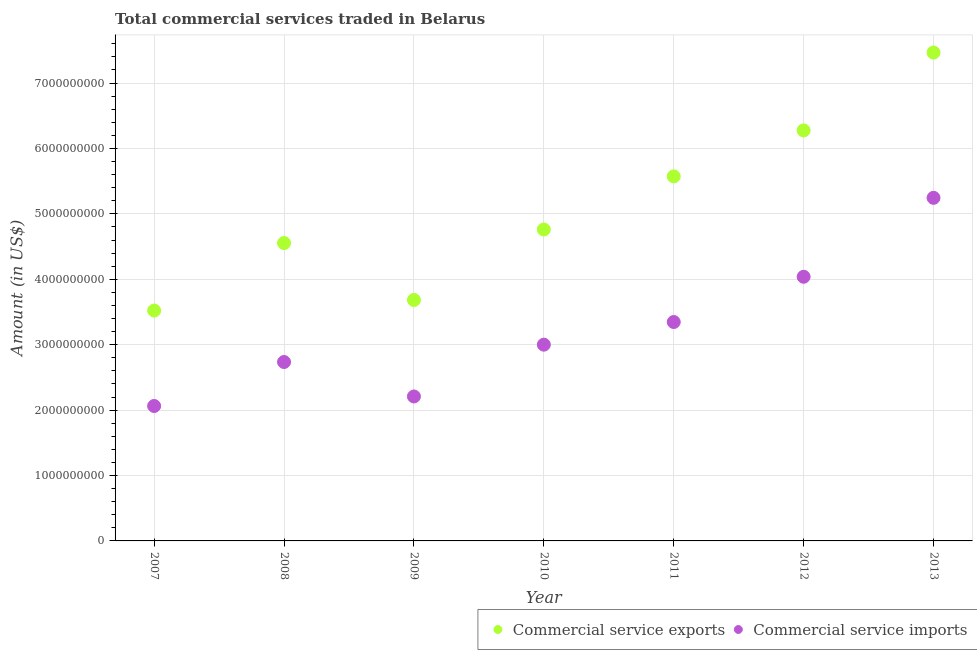Is the number of dotlines equal to the number of legend labels?
Provide a short and direct response. Yes. What is the amount of commercial service imports in 2011?
Keep it short and to the point. 3.35e+09. Across all years, what is the maximum amount of commercial service imports?
Provide a succinct answer. 5.24e+09. Across all years, what is the minimum amount of commercial service exports?
Offer a terse response. 3.52e+09. In which year was the amount of commercial service exports maximum?
Offer a terse response. 2013. What is the total amount of commercial service imports in the graph?
Ensure brevity in your answer.  2.26e+1. What is the difference between the amount of commercial service exports in 2007 and that in 2010?
Your response must be concise. -1.24e+09. What is the difference between the amount of commercial service imports in 2013 and the amount of commercial service exports in 2008?
Your answer should be very brief. 6.92e+08. What is the average amount of commercial service imports per year?
Give a very brief answer. 3.23e+09. In the year 2008, what is the difference between the amount of commercial service exports and amount of commercial service imports?
Give a very brief answer. 1.82e+09. What is the ratio of the amount of commercial service imports in 2010 to that in 2011?
Offer a very short reply. 0.9. Is the amount of commercial service imports in 2007 less than that in 2008?
Offer a terse response. Yes. What is the difference between the highest and the second highest amount of commercial service exports?
Offer a terse response. 1.19e+09. What is the difference between the highest and the lowest amount of commercial service imports?
Offer a very short reply. 3.18e+09. In how many years, is the amount of commercial service imports greater than the average amount of commercial service imports taken over all years?
Give a very brief answer. 3. Is the sum of the amount of commercial service imports in 2007 and 2011 greater than the maximum amount of commercial service exports across all years?
Make the answer very short. No. Is the amount of commercial service imports strictly greater than the amount of commercial service exports over the years?
Your response must be concise. No. How many years are there in the graph?
Ensure brevity in your answer.  7. Are the values on the major ticks of Y-axis written in scientific E-notation?
Your answer should be very brief. No. Does the graph contain any zero values?
Give a very brief answer. No. Where does the legend appear in the graph?
Provide a short and direct response. Bottom right. How many legend labels are there?
Your answer should be compact. 2. How are the legend labels stacked?
Provide a succinct answer. Horizontal. What is the title of the graph?
Keep it short and to the point. Total commercial services traded in Belarus. What is the label or title of the X-axis?
Offer a terse response. Year. What is the label or title of the Y-axis?
Offer a very short reply. Amount (in US$). What is the Amount (in US$) in Commercial service exports in 2007?
Offer a terse response. 3.52e+09. What is the Amount (in US$) in Commercial service imports in 2007?
Give a very brief answer. 2.06e+09. What is the Amount (in US$) in Commercial service exports in 2008?
Offer a very short reply. 4.55e+09. What is the Amount (in US$) in Commercial service imports in 2008?
Your answer should be very brief. 2.74e+09. What is the Amount (in US$) of Commercial service exports in 2009?
Ensure brevity in your answer.  3.68e+09. What is the Amount (in US$) of Commercial service imports in 2009?
Give a very brief answer. 2.21e+09. What is the Amount (in US$) of Commercial service exports in 2010?
Provide a short and direct response. 4.76e+09. What is the Amount (in US$) in Commercial service imports in 2010?
Keep it short and to the point. 3.00e+09. What is the Amount (in US$) in Commercial service exports in 2011?
Give a very brief answer. 5.57e+09. What is the Amount (in US$) of Commercial service imports in 2011?
Keep it short and to the point. 3.35e+09. What is the Amount (in US$) in Commercial service exports in 2012?
Your answer should be very brief. 6.28e+09. What is the Amount (in US$) in Commercial service imports in 2012?
Your answer should be compact. 4.04e+09. What is the Amount (in US$) in Commercial service exports in 2013?
Offer a terse response. 7.47e+09. What is the Amount (in US$) in Commercial service imports in 2013?
Your answer should be compact. 5.24e+09. Across all years, what is the maximum Amount (in US$) of Commercial service exports?
Make the answer very short. 7.47e+09. Across all years, what is the maximum Amount (in US$) in Commercial service imports?
Provide a succinct answer. 5.24e+09. Across all years, what is the minimum Amount (in US$) of Commercial service exports?
Ensure brevity in your answer.  3.52e+09. Across all years, what is the minimum Amount (in US$) in Commercial service imports?
Provide a short and direct response. 2.06e+09. What is the total Amount (in US$) of Commercial service exports in the graph?
Keep it short and to the point. 3.58e+1. What is the total Amount (in US$) of Commercial service imports in the graph?
Your response must be concise. 2.26e+1. What is the difference between the Amount (in US$) in Commercial service exports in 2007 and that in 2008?
Provide a succinct answer. -1.03e+09. What is the difference between the Amount (in US$) of Commercial service imports in 2007 and that in 2008?
Your response must be concise. -6.72e+08. What is the difference between the Amount (in US$) of Commercial service exports in 2007 and that in 2009?
Ensure brevity in your answer.  -1.62e+08. What is the difference between the Amount (in US$) of Commercial service imports in 2007 and that in 2009?
Give a very brief answer. -1.46e+08. What is the difference between the Amount (in US$) of Commercial service exports in 2007 and that in 2010?
Ensure brevity in your answer.  -1.24e+09. What is the difference between the Amount (in US$) of Commercial service imports in 2007 and that in 2010?
Offer a very short reply. -9.38e+08. What is the difference between the Amount (in US$) of Commercial service exports in 2007 and that in 2011?
Provide a succinct answer. -2.05e+09. What is the difference between the Amount (in US$) of Commercial service imports in 2007 and that in 2011?
Offer a very short reply. -1.28e+09. What is the difference between the Amount (in US$) in Commercial service exports in 2007 and that in 2012?
Give a very brief answer. -2.75e+09. What is the difference between the Amount (in US$) in Commercial service imports in 2007 and that in 2012?
Offer a terse response. -1.98e+09. What is the difference between the Amount (in US$) in Commercial service exports in 2007 and that in 2013?
Keep it short and to the point. -3.94e+09. What is the difference between the Amount (in US$) in Commercial service imports in 2007 and that in 2013?
Offer a terse response. -3.18e+09. What is the difference between the Amount (in US$) of Commercial service exports in 2008 and that in 2009?
Keep it short and to the point. 8.70e+08. What is the difference between the Amount (in US$) of Commercial service imports in 2008 and that in 2009?
Give a very brief answer. 5.27e+08. What is the difference between the Amount (in US$) in Commercial service exports in 2008 and that in 2010?
Your answer should be very brief. -2.08e+08. What is the difference between the Amount (in US$) in Commercial service imports in 2008 and that in 2010?
Make the answer very short. -2.65e+08. What is the difference between the Amount (in US$) of Commercial service exports in 2008 and that in 2011?
Keep it short and to the point. -1.02e+09. What is the difference between the Amount (in US$) of Commercial service imports in 2008 and that in 2011?
Ensure brevity in your answer.  -6.11e+08. What is the difference between the Amount (in US$) of Commercial service exports in 2008 and that in 2012?
Your answer should be very brief. -1.72e+09. What is the difference between the Amount (in US$) of Commercial service imports in 2008 and that in 2012?
Provide a short and direct response. -1.30e+09. What is the difference between the Amount (in US$) of Commercial service exports in 2008 and that in 2013?
Provide a succinct answer. -2.91e+09. What is the difference between the Amount (in US$) of Commercial service imports in 2008 and that in 2013?
Ensure brevity in your answer.  -2.51e+09. What is the difference between the Amount (in US$) in Commercial service exports in 2009 and that in 2010?
Ensure brevity in your answer.  -1.08e+09. What is the difference between the Amount (in US$) of Commercial service imports in 2009 and that in 2010?
Make the answer very short. -7.92e+08. What is the difference between the Amount (in US$) of Commercial service exports in 2009 and that in 2011?
Make the answer very short. -1.89e+09. What is the difference between the Amount (in US$) in Commercial service imports in 2009 and that in 2011?
Keep it short and to the point. -1.14e+09. What is the difference between the Amount (in US$) in Commercial service exports in 2009 and that in 2012?
Offer a terse response. -2.59e+09. What is the difference between the Amount (in US$) in Commercial service imports in 2009 and that in 2012?
Your answer should be very brief. -1.83e+09. What is the difference between the Amount (in US$) in Commercial service exports in 2009 and that in 2013?
Offer a terse response. -3.78e+09. What is the difference between the Amount (in US$) of Commercial service imports in 2009 and that in 2013?
Make the answer very short. -3.04e+09. What is the difference between the Amount (in US$) in Commercial service exports in 2010 and that in 2011?
Provide a short and direct response. -8.12e+08. What is the difference between the Amount (in US$) in Commercial service imports in 2010 and that in 2011?
Keep it short and to the point. -3.46e+08. What is the difference between the Amount (in US$) in Commercial service exports in 2010 and that in 2012?
Your response must be concise. -1.51e+09. What is the difference between the Amount (in US$) in Commercial service imports in 2010 and that in 2012?
Provide a short and direct response. -1.04e+09. What is the difference between the Amount (in US$) in Commercial service exports in 2010 and that in 2013?
Offer a very short reply. -2.70e+09. What is the difference between the Amount (in US$) of Commercial service imports in 2010 and that in 2013?
Provide a short and direct response. -2.24e+09. What is the difference between the Amount (in US$) in Commercial service exports in 2011 and that in 2012?
Your response must be concise. -7.03e+08. What is the difference between the Amount (in US$) in Commercial service imports in 2011 and that in 2012?
Your response must be concise. -6.92e+08. What is the difference between the Amount (in US$) of Commercial service exports in 2011 and that in 2013?
Ensure brevity in your answer.  -1.89e+09. What is the difference between the Amount (in US$) of Commercial service imports in 2011 and that in 2013?
Provide a short and direct response. -1.90e+09. What is the difference between the Amount (in US$) of Commercial service exports in 2012 and that in 2013?
Your answer should be very brief. -1.19e+09. What is the difference between the Amount (in US$) of Commercial service imports in 2012 and that in 2013?
Give a very brief answer. -1.21e+09. What is the difference between the Amount (in US$) in Commercial service exports in 2007 and the Amount (in US$) in Commercial service imports in 2008?
Provide a short and direct response. 7.87e+08. What is the difference between the Amount (in US$) in Commercial service exports in 2007 and the Amount (in US$) in Commercial service imports in 2009?
Provide a short and direct response. 1.31e+09. What is the difference between the Amount (in US$) of Commercial service exports in 2007 and the Amount (in US$) of Commercial service imports in 2010?
Provide a succinct answer. 5.22e+08. What is the difference between the Amount (in US$) of Commercial service exports in 2007 and the Amount (in US$) of Commercial service imports in 2011?
Keep it short and to the point. 1.75e+08. What is the difference between the Amount (in US$) of Commercial service exports in 2007 and the Amount (in US$) of Commercial service imports in 2012?
Your answer should be very brief. -5.16e+08. What is the difference between the Amount (in US$) in Commercial service exports in 2007 and the Amount (in US$) in Commercial service imports in 2013?
Provide a succinct answer. -1.72e+09. What is the difference between the Amount (in US$) of Commercial service exports in 2008 and the Amount (in US$) of Commercial service imports in 2009?
Give a very brief answer. 2.35e+09. What is the difference between the Amount (in US$) of Commercial service exports in 2008 and the Amount (in US$) of Commercial service imports in 2010?
Give a very brief answer. 1.55e+09. What is the difference between the Amount (in US$) of Commercial service exports in 2008 and the Amount (in US$) of Commercial service imports in 2011?
Make the answer very short. 1.21e+09. What is the difference between the Amount (in US$) in Commercial service exports in 2008 and the Amount (in US$) in Commercial service imports in 2012?
Your answer should be very brief. 5.15e+08. What is the difference between the Amount (in US$) in Commercial service exports in 2008 and the Amount (in US$) in Commercial service imports in 2013?
Give a very brief answer. -6.92e+08. What is the difference between the Amount (in US$) in Commercial service exports in 2009 and the Amount (in US$) in Commercial service imports in 2010?
Offer a terse response. 6.83e+08. What is the difference between the Amount (in US$) in Commercial service exports in 2009 and the Amount (in US$) in Commercial service imports in 2011?
Provide a short and direct response. 3.37e+08. What is the difference between the Amount (in US$) of Commercial service exports in 2009 and the Amount (in US$) of Commercial service imports in 2012?
Provide a succinct answer. -3.55e+08. What is the difference between the Amount (in US$) in Commercial service exports in 2009 and the Amount (in US$) in Commercial service imports in 2013?
Keep it short and to the point. -1.56e+09. What is the difference between the Amount (in US$) of Commercial service exports in 2010 and the Amount (in US$) of Commercial service imports in 2011?
Make the answer very short. 1.41e+09. What is the difference between the Amount (in US$) in Commercial service exports in 2010 and the Amount (in US$) in Commercial service imports in 2012?
Make the answer very short. 7.23e+08. What is the difference between the Amount (in US$) in Commercial service exports in 2010 and the Amount (in US$) in Commercial service imports in 2013?
Provide a short and direct response. -4.84e+08. What is the difference between the Amount (in US$) of Commercial service exports in 2011 and the Amount (in US$) of Commercial service imports in 2012?
Give a very brief answer. 1.54e+09. What is the difference between the Amount (in US$) of Commercial service exports in 2011 and the Amount (in US$) of Commercial service imports in 2013?
Keep it short and to the point. 3.28e+08. What is the difference between the Amount (in US$) of Commercial service exports in 2012 and the Amount (in US$) of Commercial service imports in 2013?
Your answer should be very brief. 1.03e+09. What is the average Amount (in US$) in Commercial service exports per year?
Provide a succinct answer. 5.12e+09. What is the average Amount (in US$) of Commercial service imports per year?
Your answer should be very brief. 3.23e+09. In the year 2007, what is the difference between the Amount (in US$) of Commercial service exports and Amount (in US$) of Commercial service imports?
Keep it short and to the point. 1.46e+09. In the year 2008, what is the difference between the Amount (in US$) of Commercial service exports and Amount (in US$) of Commercial service imports?
Keep it short and to the point. 1.82e+09. In the year 2009, what is the difference between the Amount (in US$) of Commercial service exports and Amount (in US$) of Commercial service imports?
Keep it short and to the point. 1.48e+09. In the year 2010, what is the difference between the Amount (in US$) of Commercial service exports and Amount (in US$) of Commercial service imports?
Your response must be concise. 1.76e+09. In the year 2011, what is the difference between the Amount (in US$) in Commercial service exports and Amount (in US$) in Commercial service imports?
Provide a succinct answer. 2.23e+09. In the year 2012, what is the difference between the Amount (in US$) in Commercial service exports and Amount (in US$) in Commercial service imports?
Your response must be concise. 2.24e+09. In the year 2013, what is the difference between the Amount (in US$) of Commercial service exports and Amount (in US$) of Commercial service imports?
Offer a terse response. 2.22e+09. What is the ratio of the Amount (in US$) of Commercial service exports in 2007 to that in 2008?
Your answer should be compact. 0.77. What is the ratio of the Amount (in US$) of Commercial service imports in 2007 to that in 2008?
Ensure brevity in your answer.  0.75. What is the ratio of the Amount (in US$) of Commercial service exports in 2007 to that in 2009?
Your answer should be very brief. 0.96. What is the ratio of the Amount (in US$) in Commercial service imports in 2007 to that in 2009?
Offer a terse response. 0.93. What is the ratio of the Amount (in US$) of Commercial service exports in 2007 to that in 2010?
Your answer should be compact. 0.74. What is the ratio of the Amount (in US$) of Commercial service imports in 2007 to that in 2010?
Give a very brief answer. 0.69. What is the ratio of the Amount (in US$) of Commercial service exports in 2007 to that in 2011?
Your response must be concise. 0.63. What is the ratio of the Amount (in US$) in Commercial service imports in 2007 to that in 2011?
Offer a terse response. 0.62. What is the ratio of the Amount (in US$) of Commercial service exports in 2007 to that in 2012?
Provide a succinct answer. 0.56. What is the ratio of the Amount (in US$) in Commercial service imports in 2007 to that in 2012?
Your answer should be very brief. 0.51. What is the ratio of the Amount (in US$) of Commercial service exports in 2007 to that in 2013?
Ensure brevity in your answer.  0.47. What is the ratio of the Amount (in US$) in Commercial service imports in 2007 to that in 2013?
Your answer should be very brief. 0.39. What is the ratio of the Amount (in US$) in Commercial service exports in 2008 to that in 2009?
Give a very brief answer. 1.24. What is the ratio of the Amount (in US$) of Commercial service imports in 2008 to that in 2009?
Offer a terse response. 1.24. What is the ratio of the Amount (in US$) in Commercial service exports in 2008 to that in 2010?
Your answer should be compact. 0.96. What is the ratio of the Amount (in US$) in Commercial service imports in 2008 to that in 2010?
Offer a very short reply. 0.91. What is the ratio of the Amount (in US$) of Commercial service exports in 2008 to that in 2011?
Make the answer very short. 0.82. What is the ratio of the Amount (in US$) of Commercial service imports in 2008 to that in 2011?
Provide a succinct answer. 0.82. What is the ratio of the Amount (in US$) of Commercial service exports in 2008 to that in 2012?
Give a very brief answer. 0.73. What is the ratio of the Amount (in US$) of Commercial service imports in 2008 to that in 2012?
Your response must be concise. 0.68. What is the ratio of the Amount (in US$) in Commercial service exports in 2008 to that in 2013?
Your response must be concise. 0.61. What is the ratio of the Amount (in US$) in Commercial service imports in 2008 to that in 2013?
Give a very brief answer. 0.52. What is the ratio of the Amount (in US$) of Commercial service exports in 2009 to that in 2010?
Make the answer very short. 0.77. What is the ratio of the Amount (in US$) of Commercial service imports in 2009 to that in 2010?
Provide a succinct answer. 0.74. What is the ratio of the Amount (in US$) in Commercial service exports in 2009 to that in 2011?
Make the answer very short. 0.66. What is the ratio of the Amount (in US$) of Commercial service imports in 2009 to that in 2011?
Provide a short and direct response. 0.66. What is the ratio of the Amount (in US$) in Commercial service exports in 2009 to that in 2012?
Your answer should be compact. 0.59. What is the ratio of the Amount (in US$) in Commercial service imports in 2009 to that in 2012?
Your response must be concise. 0.55. What is the ratio of the Amount (in US$) in Commercial service exports in 2009 to that in 2013?
Your response must be concise. 0.49. What is the ratio of the Amount (in US$) of Commercial service imports in 2009 to that in 2013?
Offer a very short reply. 0.42. What is the ratio of the Amount (in US$) of Commercial service exports in 2010 to that in 2011?
Your answer should be compact. 0.85. What is the ratio of the Amount (in US$) in Commercial service imports in 2010 to that in 2011?
Provide a succinct answer. 0.9. What is the ratio of the Amount (in US$) in Commercial service exports in 2010 to that in 2012?
Give a very brief answer. 0.76. What is the ratio of the Amount (in US$) of Commercial service imports in 2010 to that in 2012?
Give a very brief answer. 0.74. What is the ratio of the Amount (in US$) in Commercial service exports in 2010 to that in 2013?
Make the answer very short. 0.64. What is the ratio of the Amount (in US$) of Commercial service imports in 2010 to that in 2013?
Ensure brevity in your answer.  0.57. What is the ratio of the Amount (in US$) of Commercial service exports in 2011 to that in 2012?
Provide a succinct answer. 0.89. What is the ratio of the Amount (in US$) in Commercial service imports in 2011 to that in 2012?
Make the answer very short. 0.83. What is the ratio of the Amount (in US$) in Commercial service exports in 2011 to that in 2013?
Provide a short and direct response. 0.75. What is the ratio of the Amount (in US$) in Commercial service imports in 2011 to that in 2013?
Your answer should be very brief. 0.64. What is the ratio of the Amount (in US$) in Commercial service exports in 2012 to that in 2013?
Give a very brief answer. 0.84. What is the ratio of the Amount (in US$) of Commercial service imports in 2012 to that in 2013?
Give a very brief answer. 0.77. What is the difference between the highest and the second highest Amount (in US$) in Commercial service exports?
Your response must be concise. 1.19e+09. What is the difference between the highest and the second highest Amount (in US$) of Commercial service imports?
Ensure brevity in your answer.  1.21e+09. What is the difference between the highest and the lowest Amount (in US$) in Commercial service exports?
Provide a short and direct response. 3.94e+09. What is the difference between the highest and the lowest Amount (in US$) in Commercial service imports?
Offer a very short reply. 3.18e+09. 